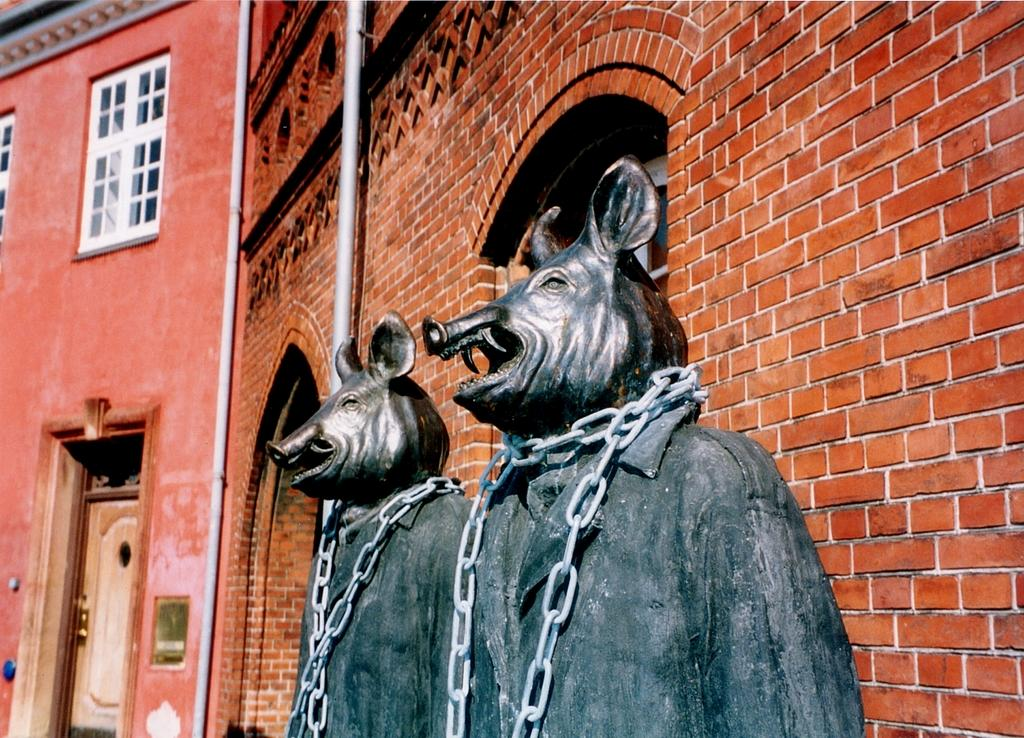What can be found in the center of the image? There are two statues in the center of the image. What is connecting the statues? There is a chain on the statues. What can be seen in the background of the image? There are buildings and pipes in the background of the image. What type of lace can be seen on the statues in the image? There is no lace present on the statues in the image. Is there a trail leading to the statues in the image? There is no trail visible in the image; it only shows the statues, the chain, and the background elements. 